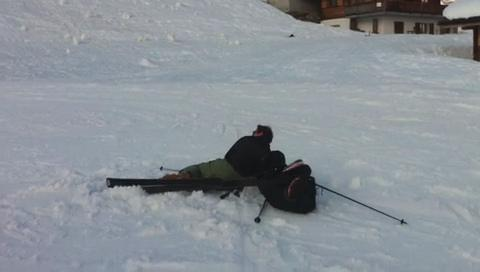What happened to this person? Please explain your reasoning. fell down. The person fell. 